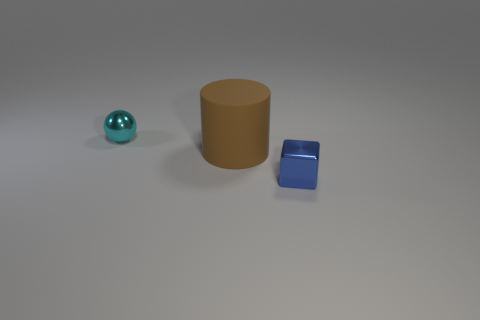Add 2 metal balls. How many objects exist? 5 Subtract all spheres. How many objects are left? 2 Add 1 brown cylinders. How many brown cylinders are left? 2 Add 1 small purple metal cylinders. How many small purple metal cylinders exist? 1 Subtract 0 green cylinders. How many objects are left? 3 Subtract all brown rubber things. Subtract all tiny blue cubes. How many objects are left? 1 